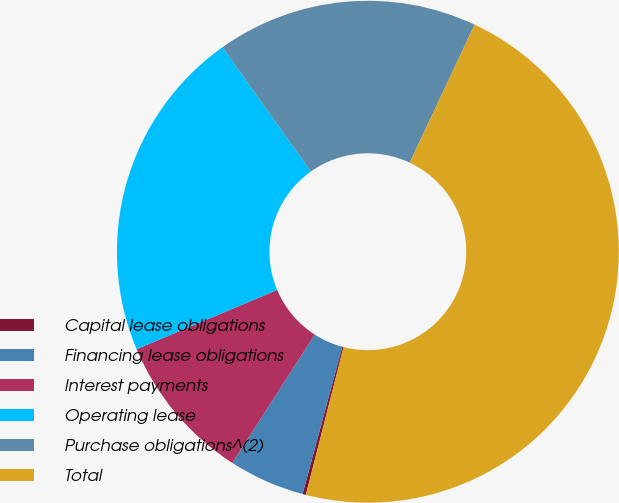Convert chart to OTSL. <chart><loc_0><loc_0><loc_500><loc_500><pie_chart><fcel>Capital lease obligations<fcel>Financing lease obligations<fcel>Interest payments<fcel>Operating lease<fcel>Purchase obligations^(2)<fcel>Total<nl><fcel>0.22%<fcel>4.89%<fcel>9.57%<fcel>21.51%<fcel>16.83%<fcel>46.98%<nl></chart> 